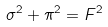<formula> <loc_0><loc_0><loc_500><loc_500>\sigma ^ { 2 } + \pi ^ { 2 } = F ^ { 2 }</formula> 